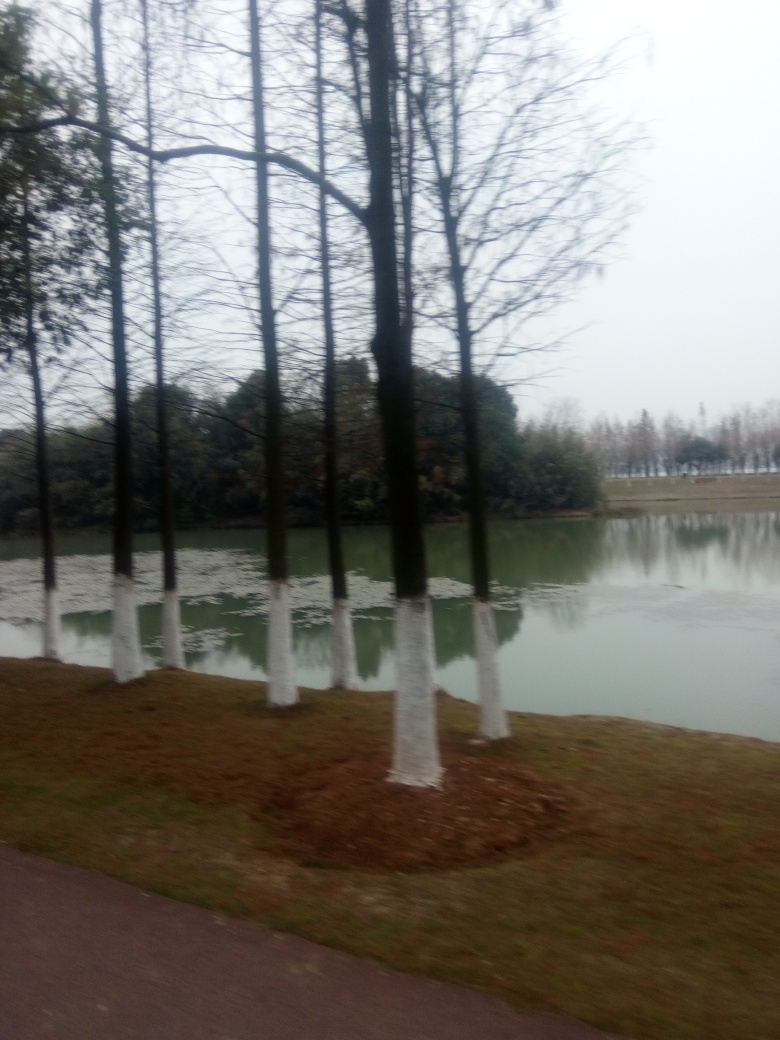Does this location appear to be a natural setting or a curated park environment? This location seems to be a curated park environment, as indicated by the manicured appearance of the tree bases and the well-maintained pathway. 